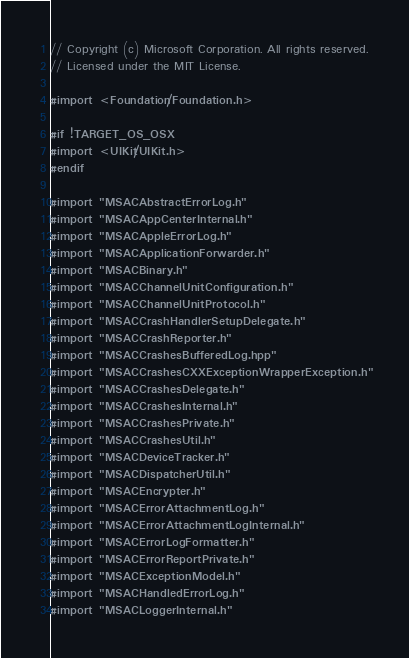Convert code to text. <code><loc_0><loc_0><loc_500><loc_500><_ObjectiveC_>// Copyright (c) Microsoft Corporation. All rights reserved.
// Licensed under the MIT License.

#import <Foundation/Foundation.h>

#if !TARGET_OS_OSX
#import <UIKit/UIKit.h>
#endif

#import "MSACAbstractErrorLog.h"
#import "MSACAppCenterInternal.h"
#import "MSACAppleErrorLog.h"
#import "MSACApplicationForwarder.h"
#import "MSACBinary.h"
#import "MSACChannelUnitConfiguration.h"
#import "MSACChannelUnitProtocol.h"
#import "MSACCrashHandlerSetupDelegate.h"
#import "MSACCrashReporter.h"
#import "MSACCrashesBufferedLog.hpp"
#import "MSACCrashesCXXExceptionWrapperException.h"
#import "MSACCrashesDelegate.h"
#import "MSACCrashesInternal.h"
#import "MSACCrashesPrivate.h"
#import "MSACCrashesUtil.h"
#import "MSACDeviceTracker.h"
#import "MSACDispatcherUtil.h"
#import "MSACEncrypter.h"
#import "MSACErrorAttachmentLog.h"
#import "MSACErrorAttachmentLogInternal.h"
#import "MSACErrorLogFormatter.h"
#import "MSACErrorReportPrivate.h"
#import "MSACExceptionModel.h"
#import "MSACHandledErrorLog.h"
#import "MSACLoggerInternal.h"</code> 